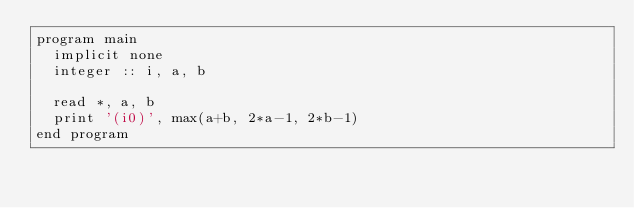<code> <loc_0><loc_0><loc_500><loc_500><_FORTRAN_>program main
  implicit none
  integer :: i, a, b

  read *, a, b
  print '(i0)', max(a+b, 2*a-1, 2*b-1)
end program</code> 